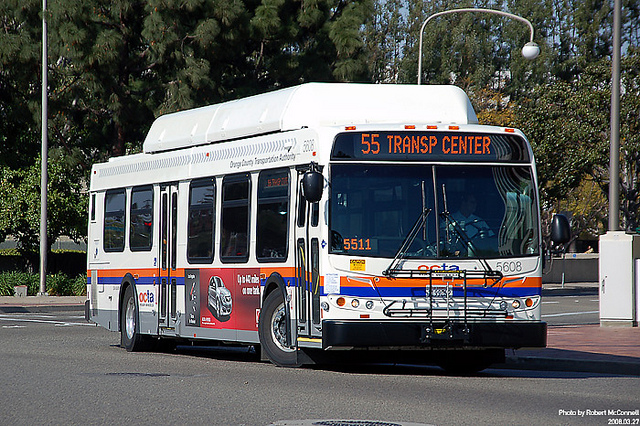<image>When was the bus made? I don't know when the bus was made. The year could range from 1990 to 2012. What does the advertisement on the side of the bus say? I can't read the advertisement on the side of the bus. It could say 'car for sale', 'lexus', 'drive on in 2016', or 'ocala'. What does the advertisement on the side of the bus say? I don't know what the advertisement on the side of the bus says. It can't be read. When was the bus made? I am not sure when the bus was made. The possible years could be 1990, 2000, 2010, 2012, or even 2005. 